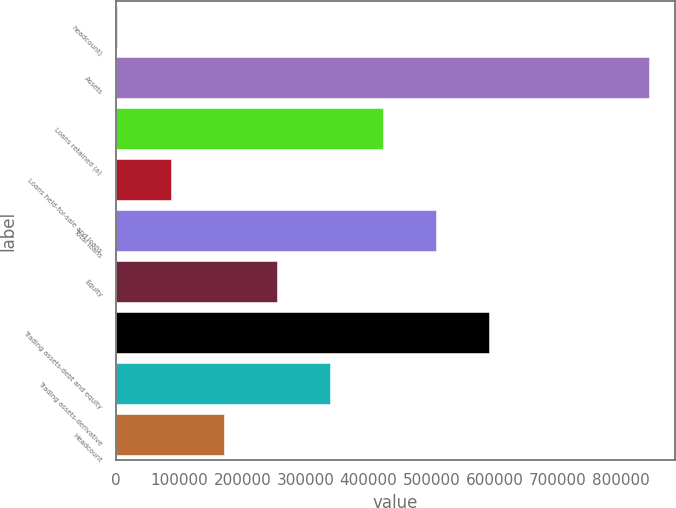Convert chart. <chart><loc_0><loc_0><loc_500><loc_500><bar_chart><fcel>headcount)<fcel>Assets<fcel>Loans retained (a)<fcel>Loans held-for-sale and loans<fcel>Total loans<fcel>Equity<fcel>Trading assets-debt and equity<fcel>Trading assets-derivative<fcel>Headcount<nl><fcel>2013<fcel>843577<fcel>422795<fcel>86169.4<fcel>506951<fcel>254482<fcel>591108<fcel>338639<fcel>170326<nl></chart> 